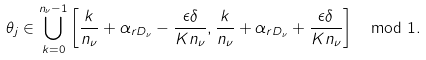<formula> <loc_0><loc_0><loc_500><loc_500>\theta _ { j } \in \bigcup _ { k = 0 } ^ { n _ { \nu } - 1 } \left [ \frac { k } { n _ { \nu } } + \alpha _ { r D _ { \nu } } - \frac { \epsilon \delta } { K n _ { \nu } } , \frac { k } { n _ { \nu } } + \alpha _ { r D _ { \nu } } + \frac { \epsilon \delta } { K n _ { \nu } } \right ] \mod 1 .</formula> 